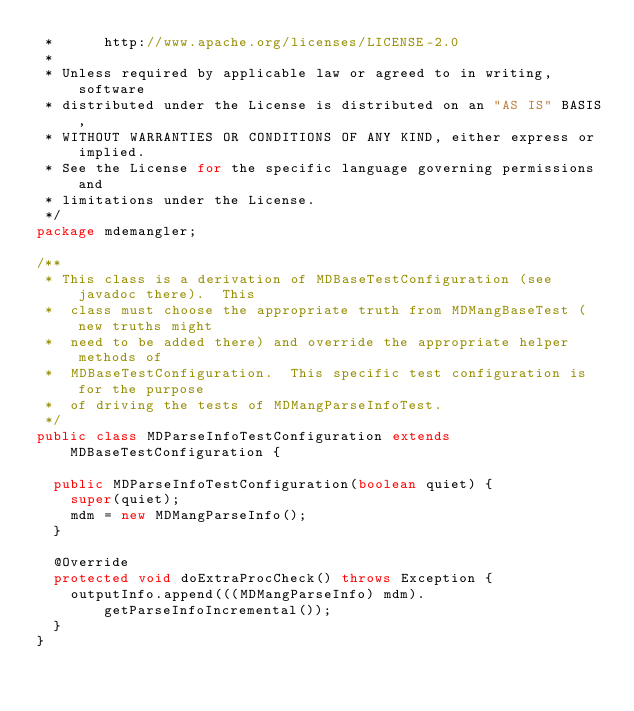Convert code to text. <code><loc_0><loc_0><loc_500><loc_500><_Java_> *      http://www.apache.org/licenses/LICENSE-2.0
 * 
 * Unless required by applicable law or agreed to in writing, software
 * distributed under the License is distributed on an "AS IS" BASIS,
 * WITHOUT WARRANTIES OR CONDITIONS OF ANY KIND, either express or implied.
 * See the License for the specific language governing permissions and
 * limitations under the License.
 */
package mdemangler;

/**
 * This class is a derivation of MDBaseTestConfiguration (see javadoc there).  This
 *  class must choose the appropriate truth from MDMangBaseTest (new truths might
 *  need to be added there) and override the appropriate helper methods of
 *  MDBaseTestConfiguration.  This specific test configuration is for the purpose
 *  of driving the tests of MDMangParseInfoTest.
 */
public class MDParseInfoTestConfiguration extends MDBaseTestConfiguration {

	public MDParseInfoTestConfiguration(boolean quiet) {
		super(quiet);
		mdm = new MDMangParseInfo();
	}

	@Override
	protected void doExtraProcCheck() throws Exception {
		outputInfo.append(((MDMangParseInfo) mdm).getParseInfoIncremental());
	}
}
</code> 